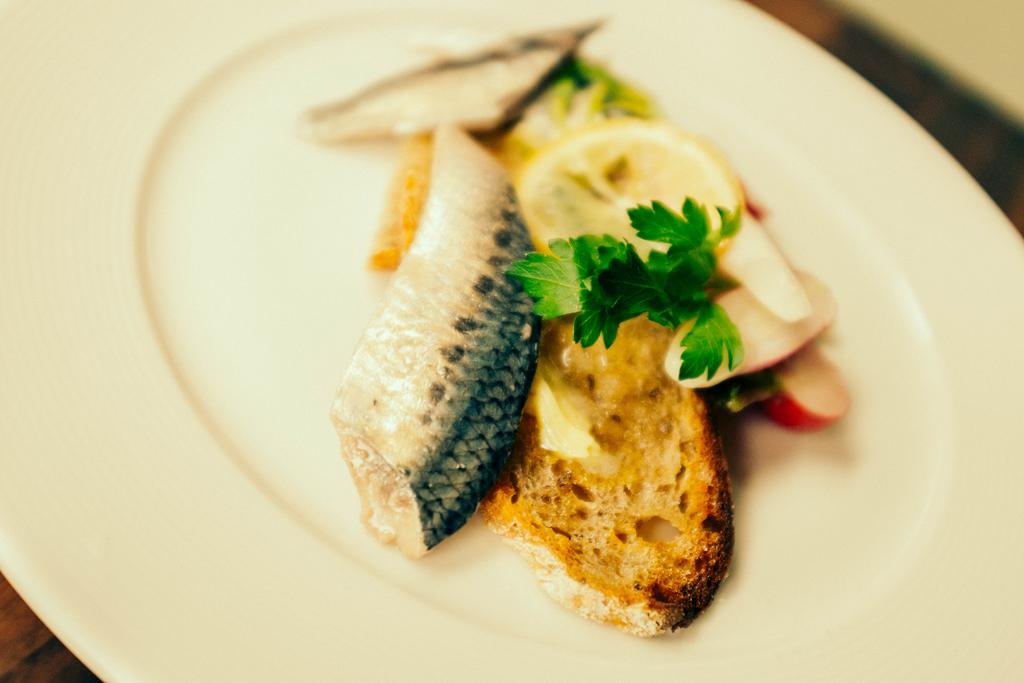What is on the white plate in the image? There is meat, a bread slice, a lemon, and leafy vegetable on the white plate in the image. What type of floor is visible in the image? The floor in the image appears to be wooden. Can you see any ants carrying the lemon in the image? There are no ants present in the image, and therefore no such activity can be observed. 